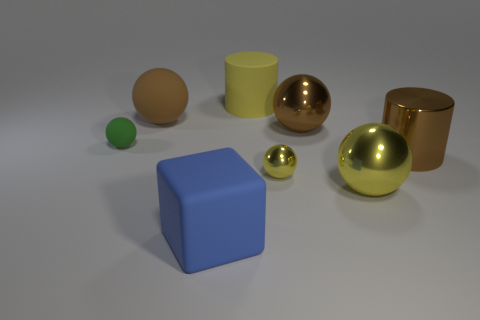How many other things are the same color as the big matte cylinder?
Offer a terse response. 2. There is a large ball that is the same color as the small metal object; what is its material?
Your response must be concise. Metal. There is a brown ball to the right of the brown matte thing; how many big balls are behind it?
Provide a short and direct response. 1. Are there any rubber blocks that have the same color as the small metallic object?
Keep it short and to the point. No. Do the blue rubber thing and the rubber cylinder have the same size?
Offer a very short reply. Yes. Does the tiny metallic ball have the same color as the big rubber sphere?
Make the answer very short. No. There is a blue cube that is in front of the large brown ball that is on the left side of the small yellow object; what is it made of?
Keep it short and to the point. Rubber. There is another tiny object that is the same shape as the tiny yellow object; what is it made of?
Your answer should be compact. Rubber. Is the size of the metallic cylinder behind the blue object the same as the matte cube?
Provide a short and direct response. Yes. How many rubber objects are either large blue objects or large brown objects?
Your answer should be compact. 2. 